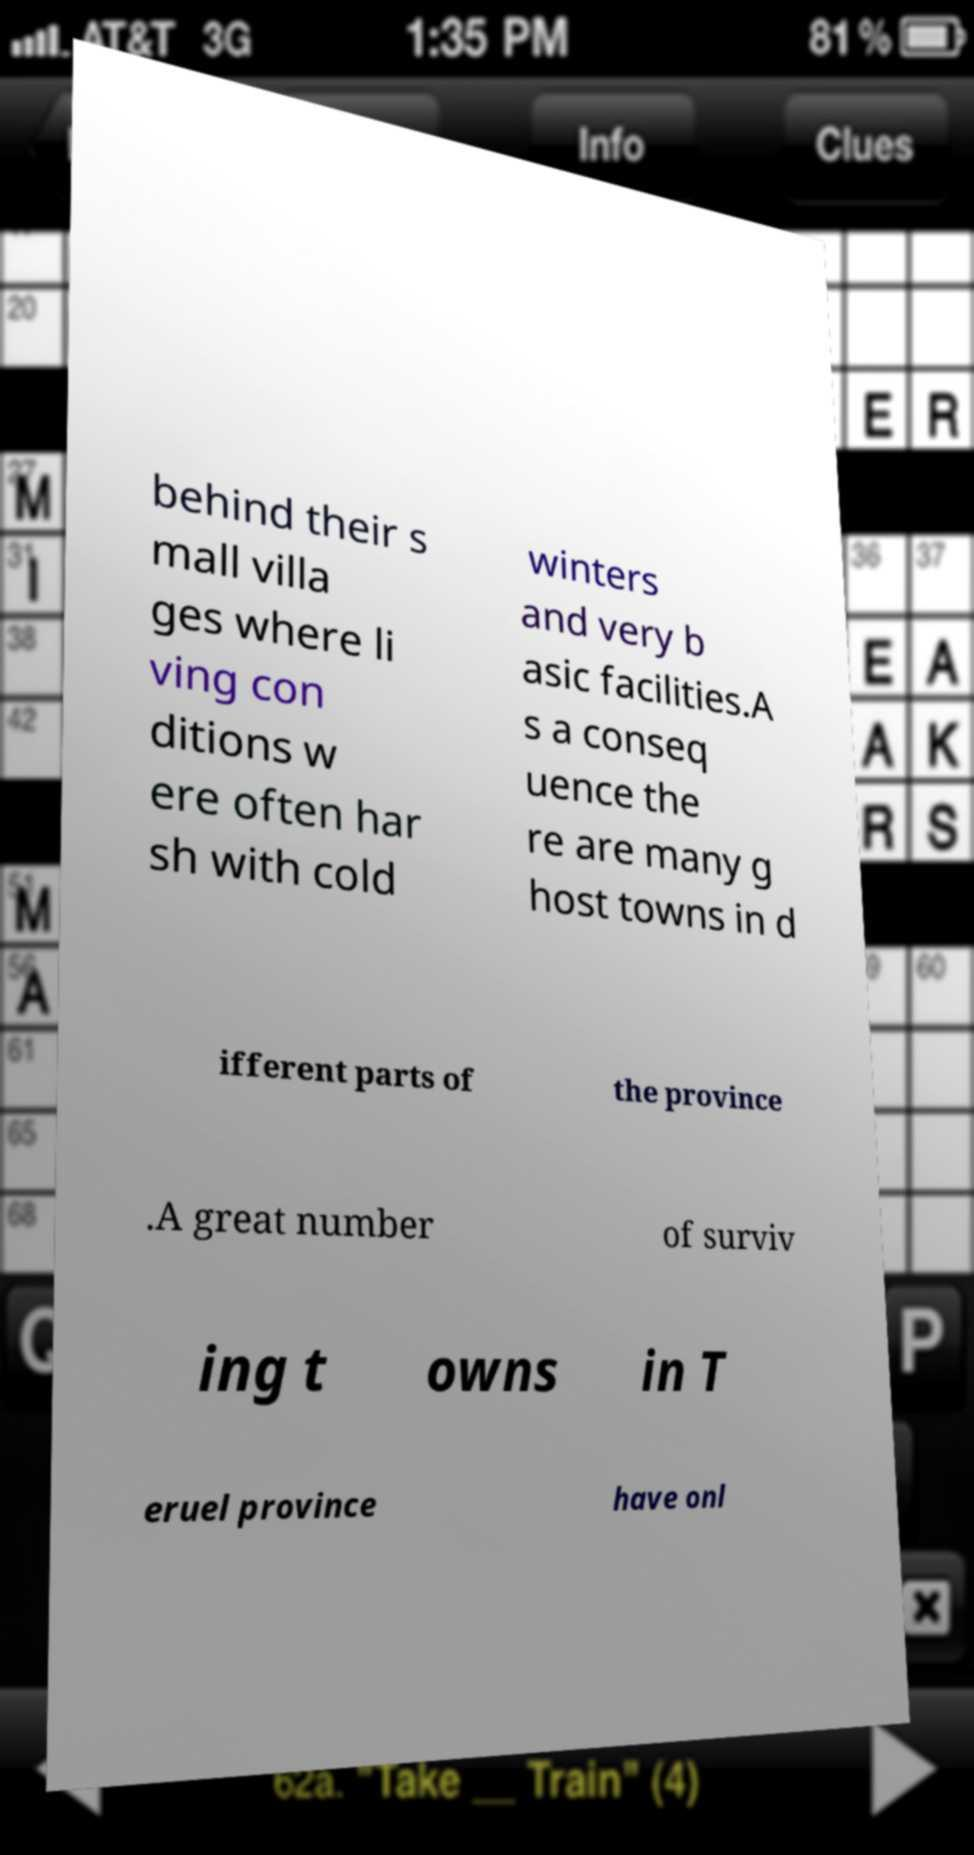Can you read and provide the text displayed in the image?This photo seems to have some interesting text. Can you extract and type it out for me? behind their s mall villa ges where li ving con ditions w ere often har sh with cold winters and very b asic facilities.A s a conseq uence the re are many g host towns in d ifferent parts of the province .A great number of surviv ing t owns in T eruel province have onl 